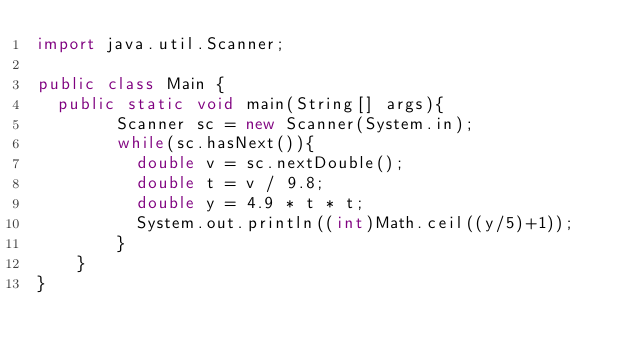Convert code to text. <code><loc_0><loc_0><loc_500><loc_500><_Java_>import java.util.Scanner;

public class Main {
	public static void main(String[] args){
        Scanner sc = new Scanner(System.in);
        while(sc.hasNext()){
        	double v = sc.nextDouble();
        	double t = v / 9.8;
        	double y = 4.9 * t * t;
        	System.out.println((int)Math.ceil((y/5)+1));
        }
    }
}</code> 